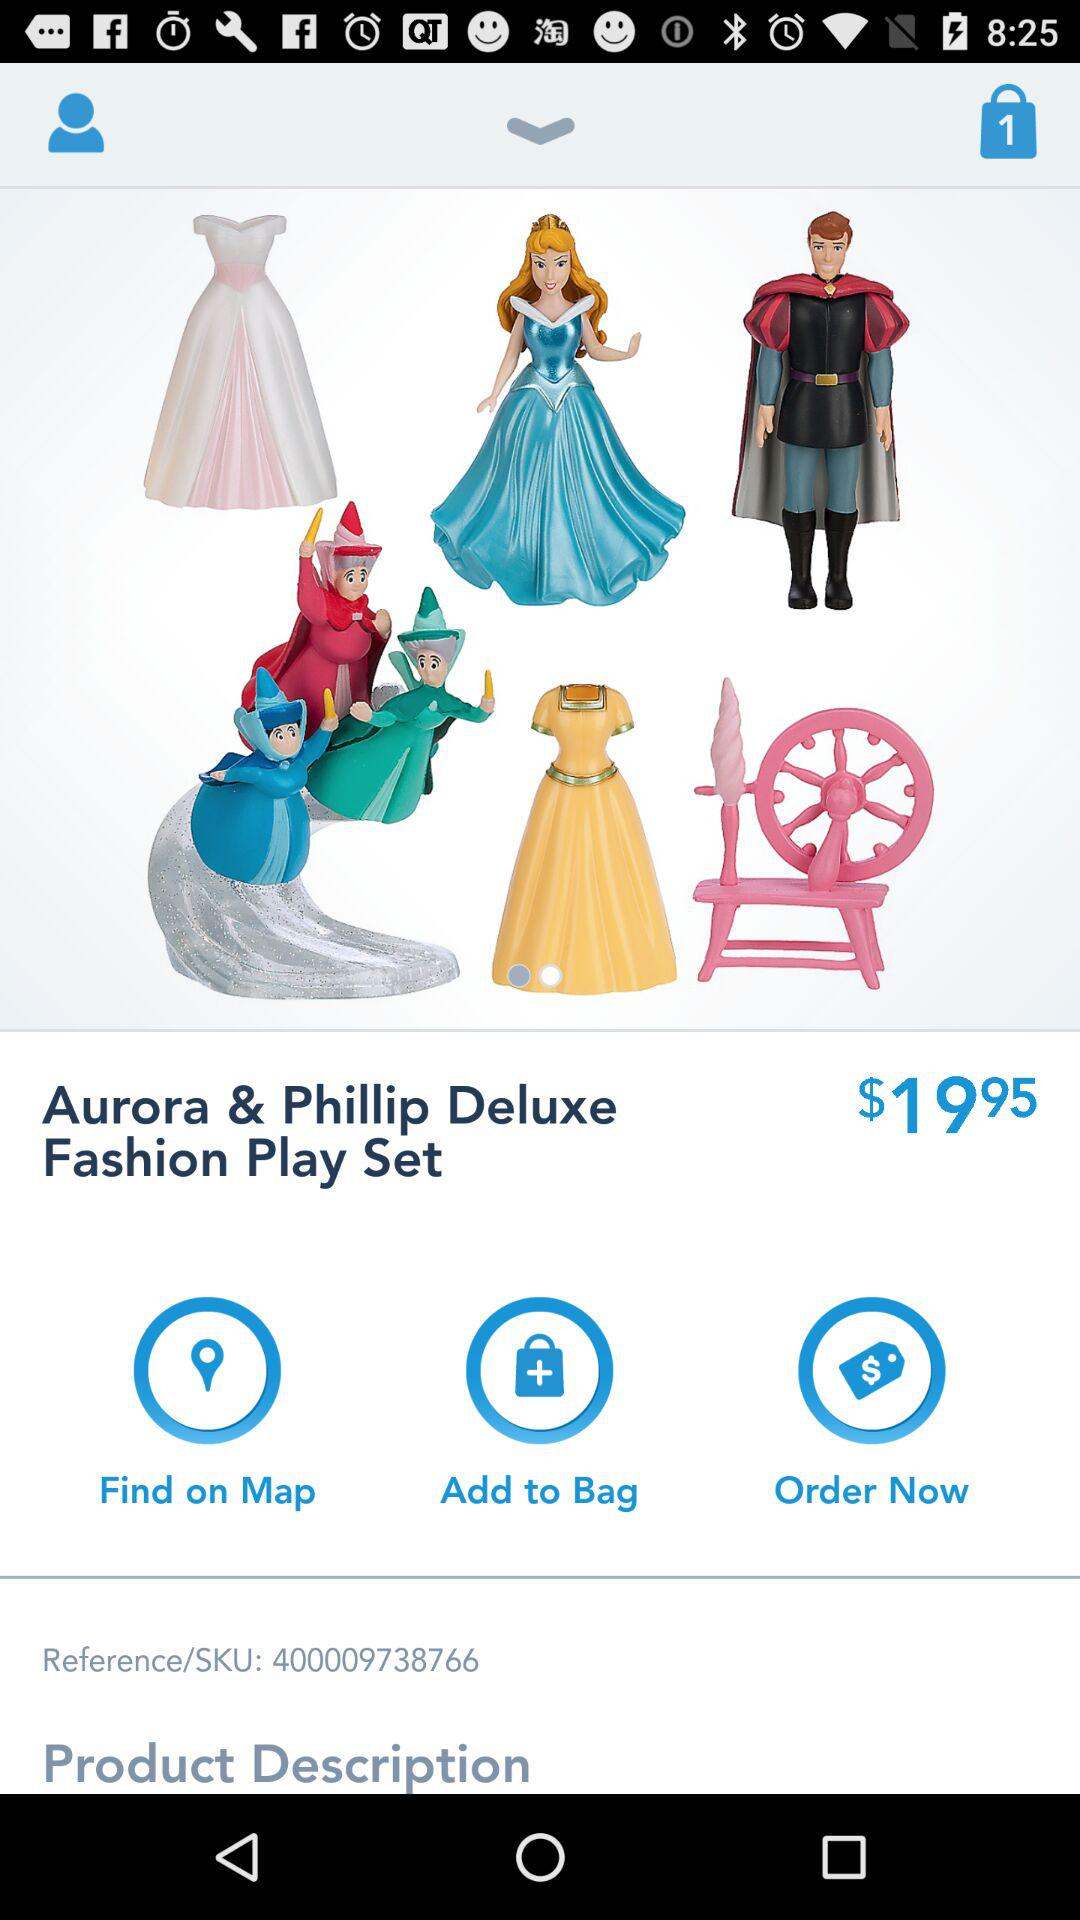What's the price of "Aurora & Phillip Deluxe Fashion Play Set"? The price is $19.95. 